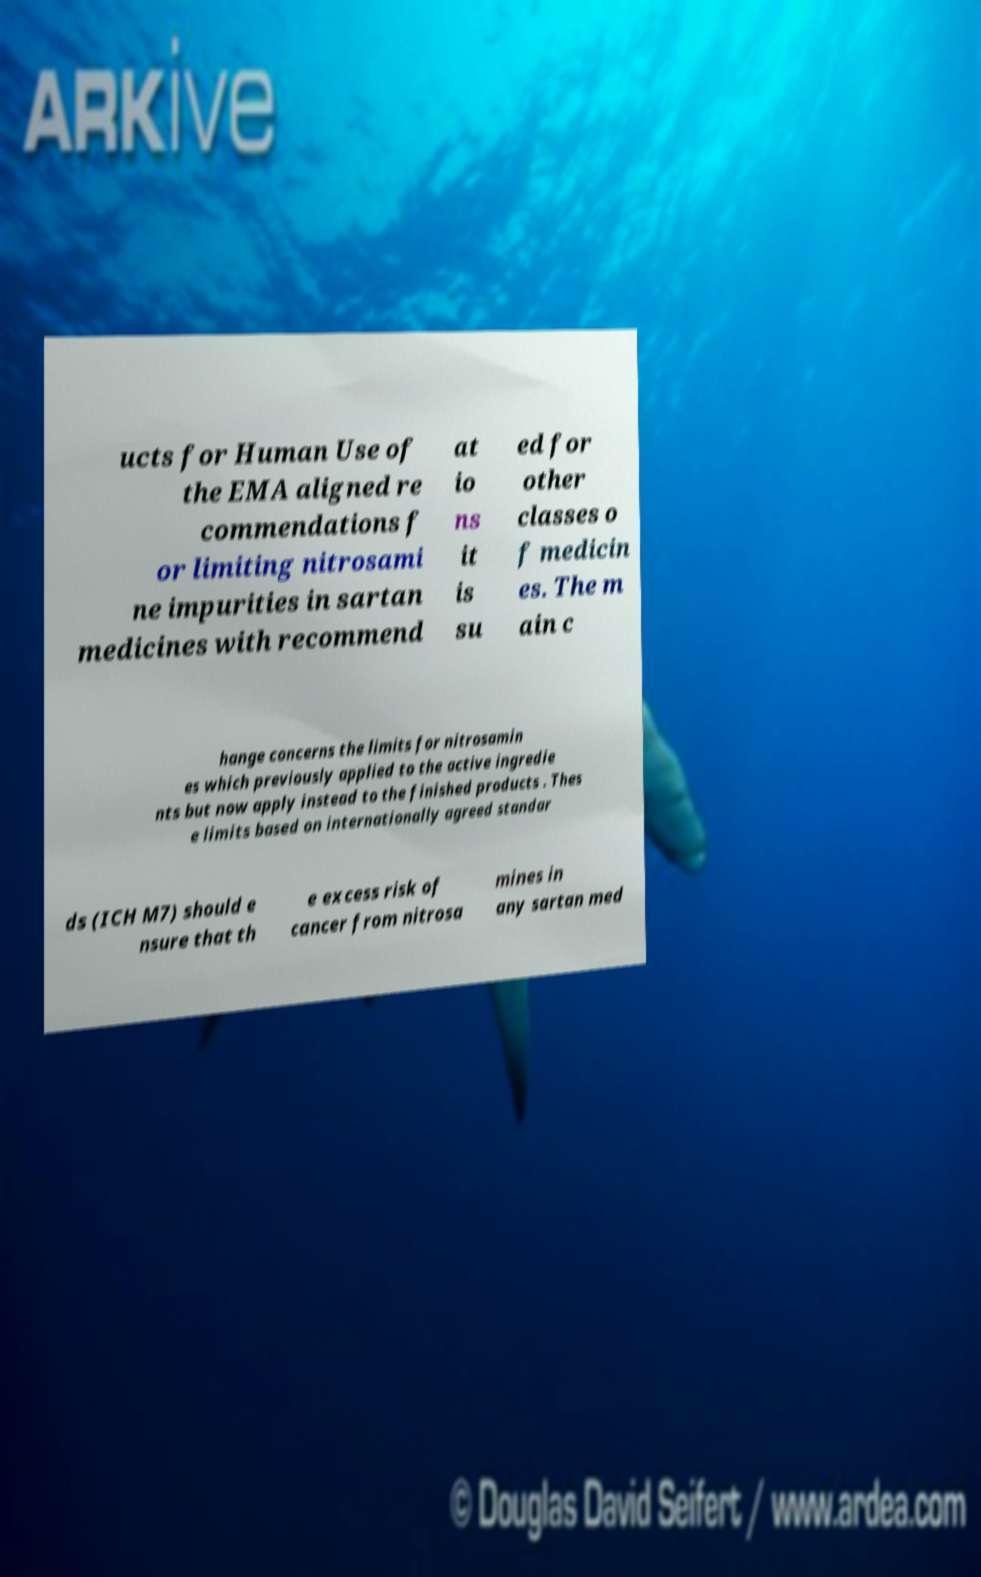Can you accurately transcribe the text from the provided image for me? ucts for Human Use of the EMA aligned re commendations f or limiting nitrosami ne impurities in sartan medicines with recommend at io ns it is su ed for other classes o f medicin es. The m ain c hange concerns the limits for nitrosamin es which previously applied to the active ingredie nts but now apply instead to the finished products . Thes e limits based on internationally agreed standar ds (ICH M7) should e nsure that th e excess risk of cancer from nitrosa mines in any sartan med 